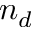<formula> <loc_0><loc_0><loc_500><loc_500>n _ { d }</formula> 